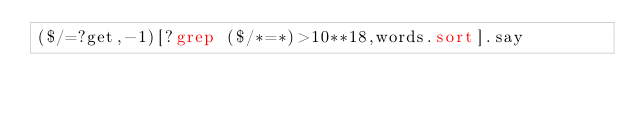<code> <loc_0><loc_0><loc_500><loc_500><_Perl_>($/=?get,-1)[?grep ($/*=*)>10**18,words.sort].say</code> 